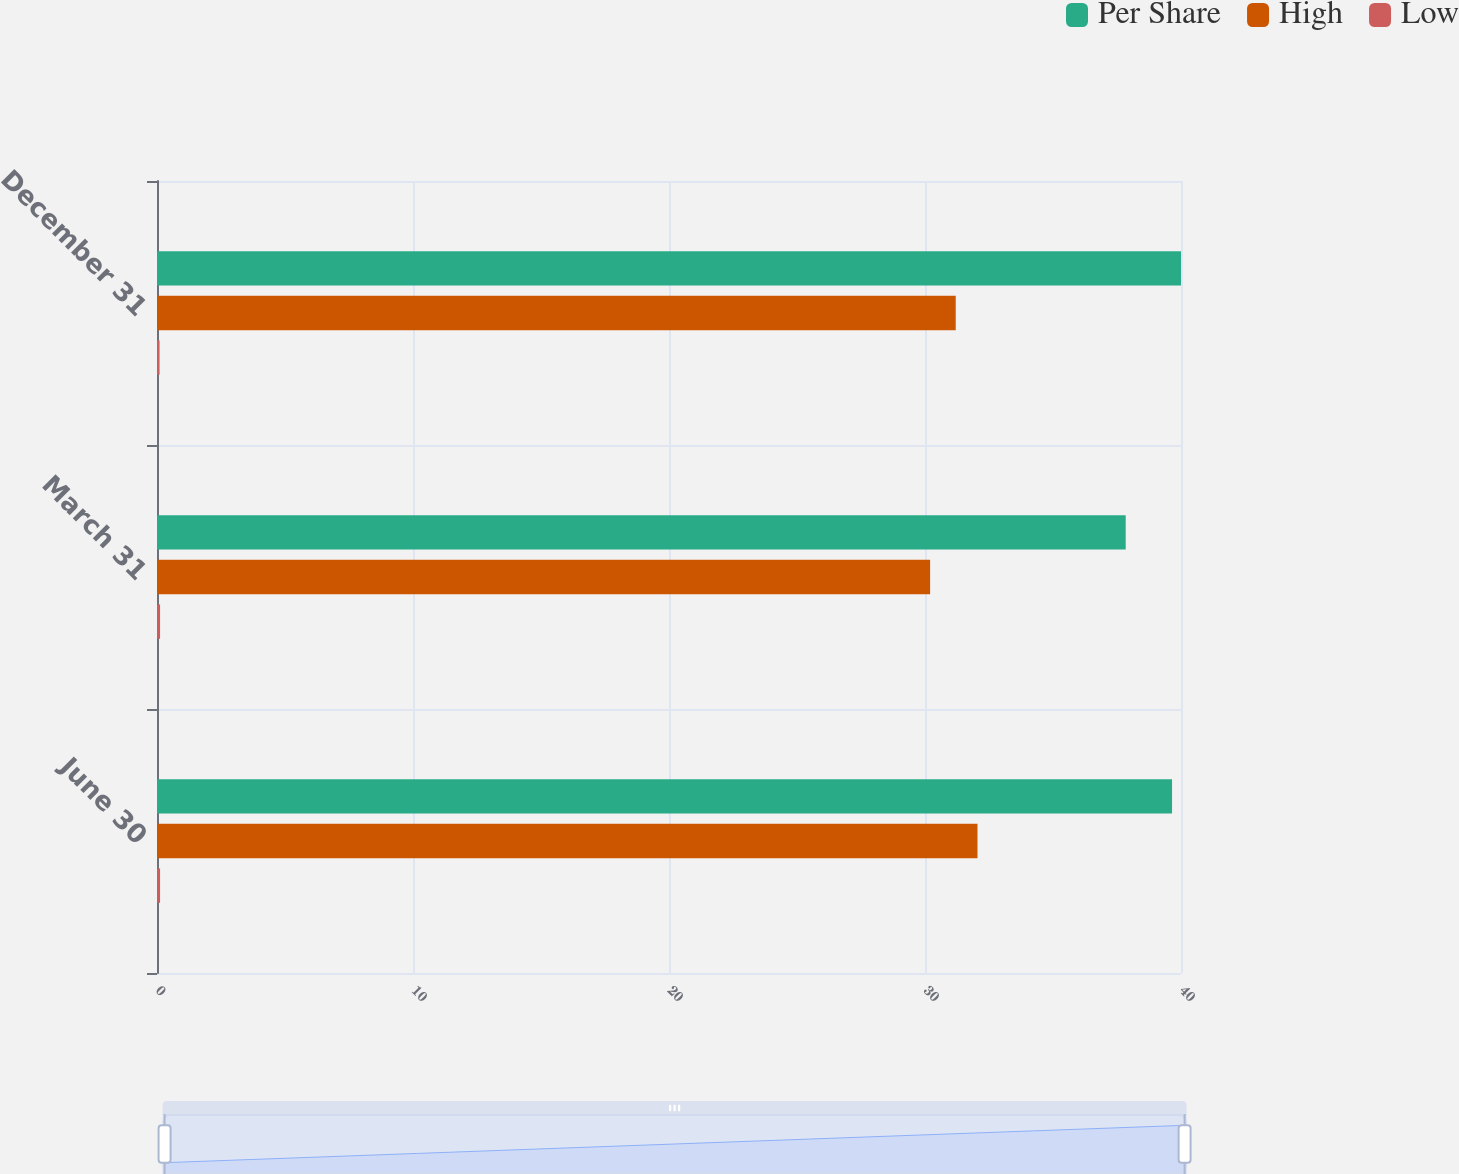Convert chart. <chart><loc_0><loc_0><loc_500><loc_500><stacked_bar_chart><ecel><fcel>June 30<fcel>March 31<fcel>December 31<nl><fcel>Per Share<fcel>39.65<fcel>37.84<fcel>40<nl><fcel>High<fcel>32.05<fcel>30.2<fcel>31.2<nl><fcel>Low<fcel>0.12<fcel>0.12<fcel>0.1<nl></chart> 